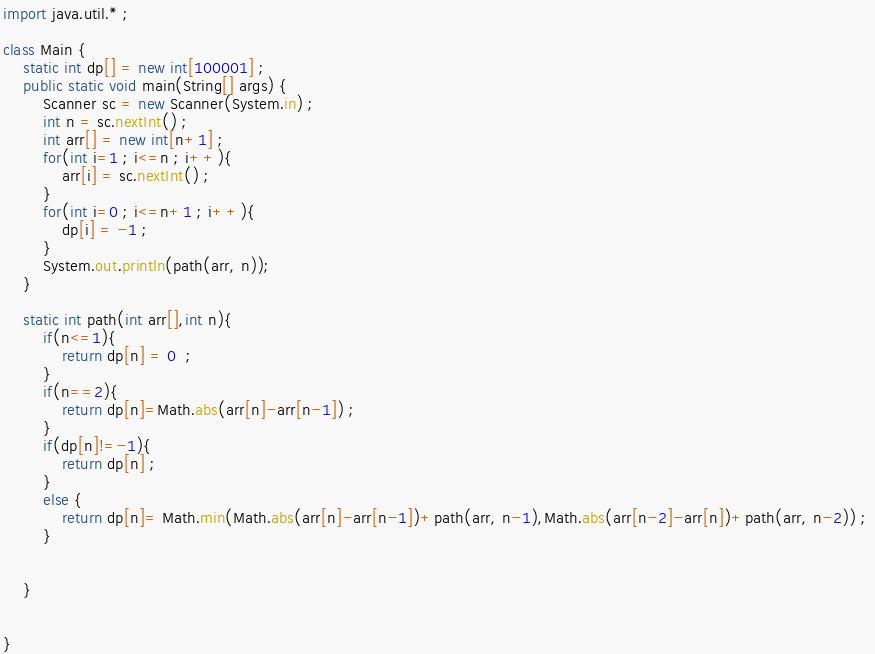Convert code to text. <code><loc_0><loc_0><loc_500><loc_500><_Java_>
import java.util.* ;

class Main {
    static int dp[] = new int[100001] ; 
    public static void main(String[] args) {
        Scanner sc = new Scanner(System.in) ;
        int n = sc.nextInt() ; 
        int arr[] = new int[n+1] ; 
        for(int i=1 ; i<=n ; i++){
            arr[i] = sc.nextInt() ; 
        }
        for(int i=0 ; i<=n+1 ; i++){
            dp[i] = -1 ; 
        }
        System.out.println(path(arr, n)); 
    }

    static int path(int arr[],int n){
        if(n<=1){
            return dp[n] = 0  ; 
        }
        if(n==2){
            return dp[n]=Math.abs(arr[n]-arr[n-1]) ;
        }
        if(dp[n]!=-1){
            return dp[n] ; 
        }
        else {
            return dp[n]= Math.min(Math.abs(arr[n]-arr[n-1])+path(arr, n-1),Math.abs(arr[n-2]-arr[n])+path(arr, n-2)) ; 
        }
       
    
    }

    
}
</code> 